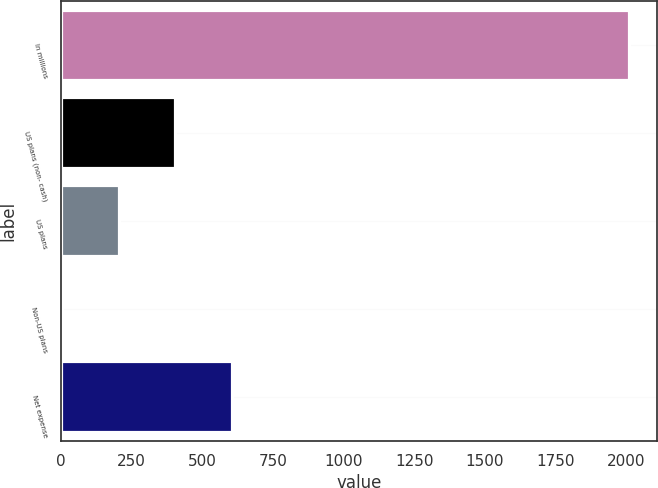Convert chart. <chart><loc_0><loc_0><loc_500><loc_500><bar_chart><fcel>In millions<fcel>US plans (non- cash)<fcel>US plans<fcel>Non-US plans<fcel>Net expense<nl><fcel>2009<fcel>404.2<fcel>203.6<fcel>3<fcel>604.8<nl></chart> 